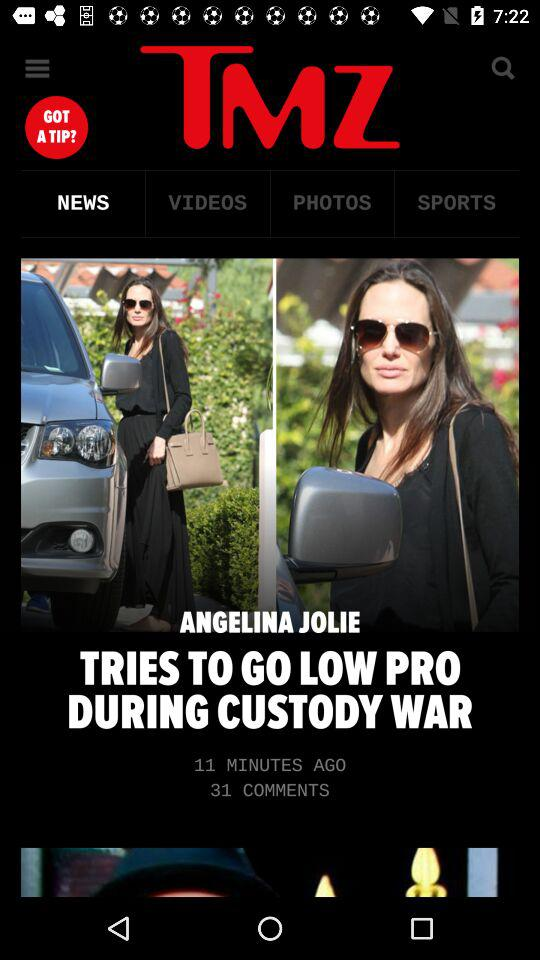Which tab is selected? The selected tab is "NEWS". 